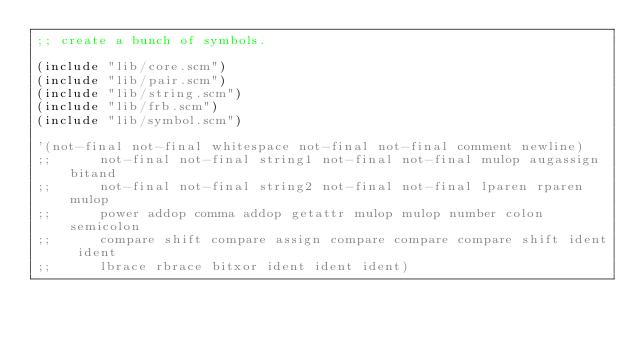Convert code to text. <code><loc_0><loc_0><loc_500><loc_500><_Scheme_>;; create a bunch of symbols.

(include "lib/core.scm")
(include "lib/pair.scm")
(include "lib/string.scm")
(include "lib/frb.scm")
(include "lib/symbol.scm")

'(not-final not-final whitespace not-final not-final comment newline)
;;	    not-final not-final string1 not-final not-final mulop augassign bitand
;;	    not-final not-final string2 not-final not-final lparen rparen mulop
;;	    power addop comma addop getattr mulop mulop number colon semicolon
;;	    compare shift compare assign compare compare compare shift ident ident
;;	    lbrace rbrace bitxor ident ident ident)
</code> 